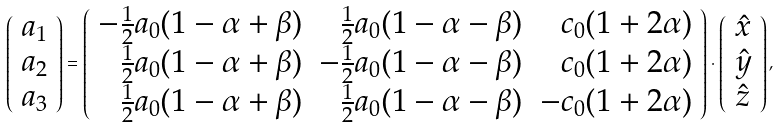<formula> <loc_0><loc_0><loc_500><loc_500>\left ( \begin{array} { c } { a } _ { 1 } \\ { a } _ { 2 } \\ { a } _ { 3 } \end{array} \right ) = \left ( \begin{array} { r r r } - \frac { 1 } { 2 } a _ { 0 } ( 1 - \alpha + \beta ) & \frac { 1 } { 2 } a _ { 0 } ( 1 - \alpha - \beta ) & c _ { 0 } ( 1 + 2 \alpha ) \\ \frac { 1 } { 2 } a _ { 0 } ( 1 - \alpha + \beta ) & - \frac { 1 } { 2 } a _ { 0 } ( 1 - \alpha - \beta ) & c _ { 0 } ( 1 + 2 \alpha ) \\ \frac { 1 } { 2 } a _ { 0 } ( 1 - \alpha + \beta ) & \frac { 1 } { 2 } a _ { 0 } ( 1 - \alpha - \beta ) & - c _ { 0 } ( 1 + 2 \alpha ) \\ \end{array} \right ) \cdot \left ( \begin{array} { c } \hat { x } \\ \hat { y } \\ \hat { z } \end{array} \right ) ,</formula> 